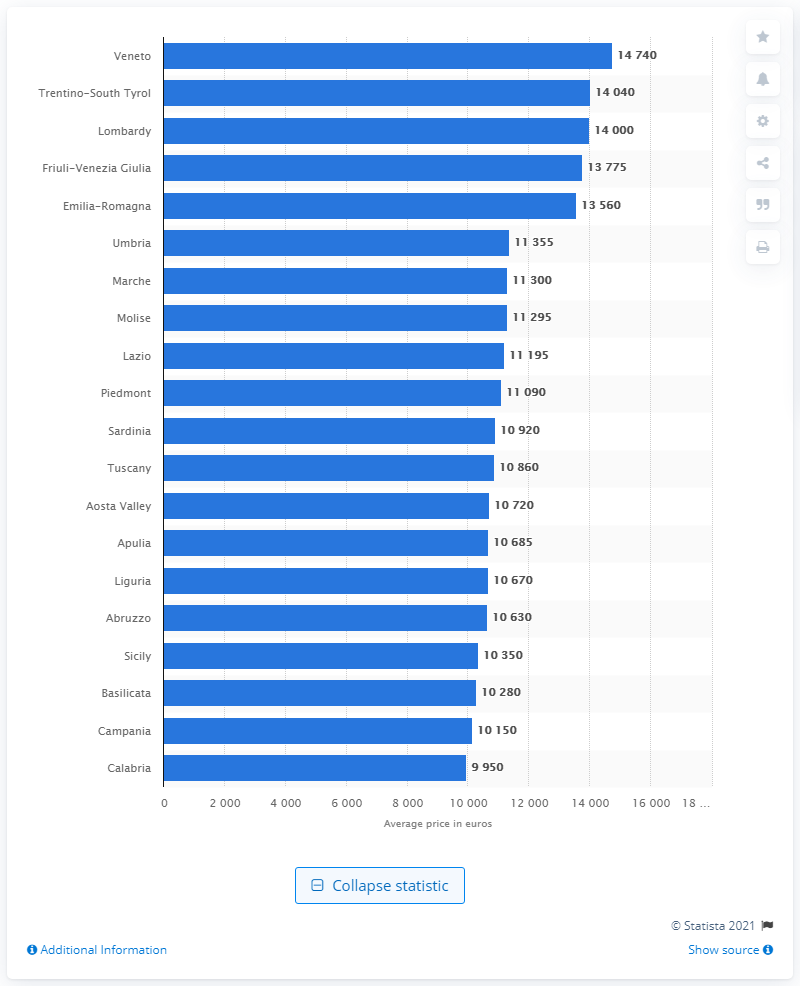Highlight a few significant elements in this photo. In 2017, the highest price of used cars was recorded in Veneto, Italy. 